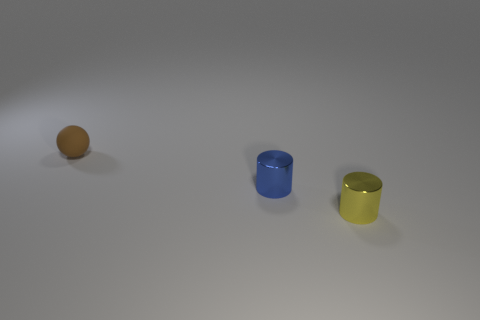Are these objects arranged in any specific pattern? Yes, they are arranged in a diagonal line across the image, with even spacing between them, which could suggest a deliberate placement for display or comparison. 